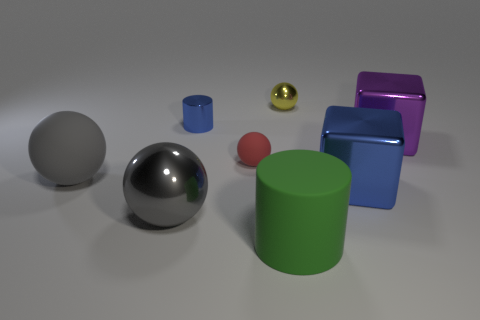What is the material of the blue object that is the same shape as the green thing?
Your response must be concise. Metal. What size is the shiny cube that is the same color as the shiny cylinder?
Your answer should be very brief. Large. Is the number of large yellow metal things greater than the number of red matte spheres?
Your answer should be compact. No. Does the large cylinder have the same color as the small metal sphere?
Your response must be concise. No. How many objects are small blue metallic things or metallic things behind the small blue thing?
Your answer should be very brief. 2. What number of other things are the same shape as the gray metallic thing?
Provide a short and direct response. 3. Is the number of large shiny cubes that are left of the red rubber thing less than the number of big things that are to the left of the yellow shiny ball?
Your response must be concise. Yes. There is a big purple object that is the same material as the blue cube; what shape is it?
Your response must be concise. Cube. Is there anything else that has the same color as the matte cylinder?
Offer a terse response. No. The matte sphere behind the big rubber object left of the tiny red object is what color?
Your answer should be compact. Red. 